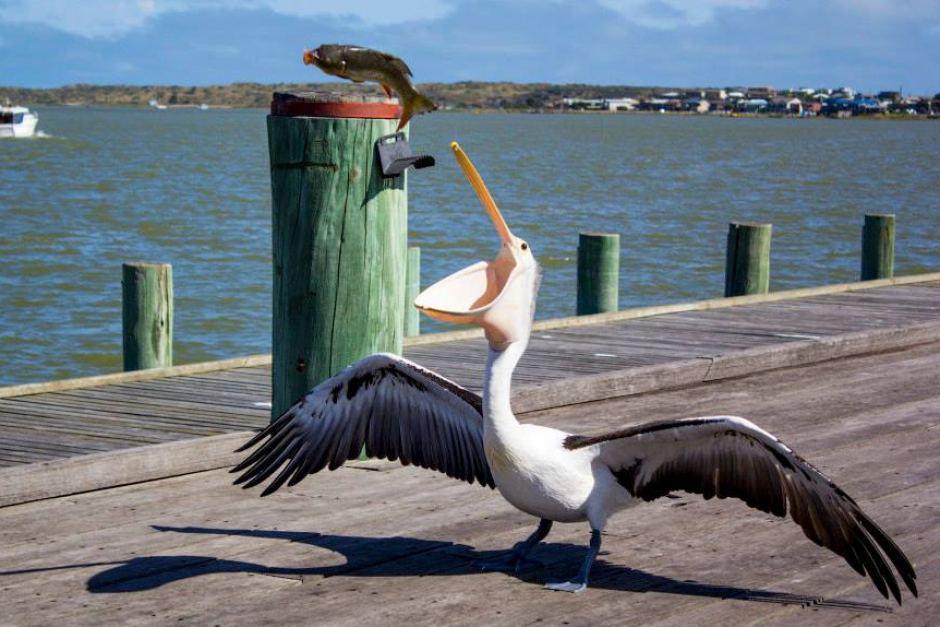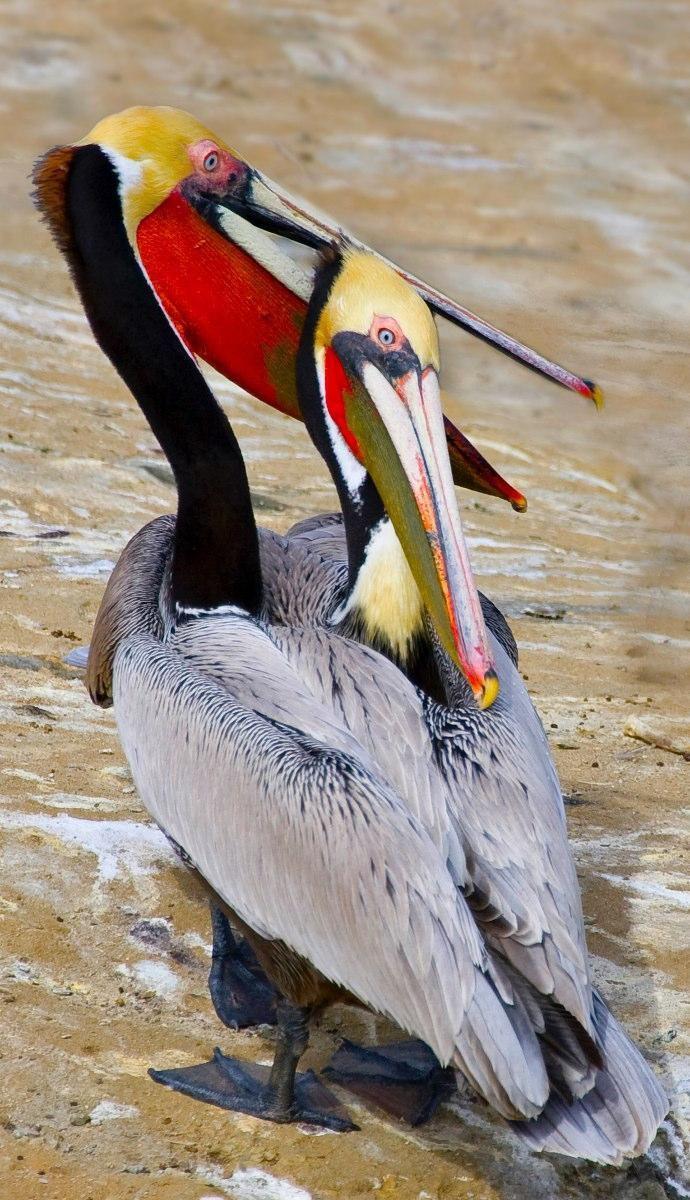The first image is the image on the left, the second image is the image on the right. Analyze the images presented: Is the assertion "There is an animal directly on top of a wooden post." valid? Answer yes or no. Yes. The first image is the image on the left, the second image is the image on the right. Considering the images on both sides, is "There is at least one image of one or more pelicans standing on a dock." valid? Answer yes or no. Yes. 